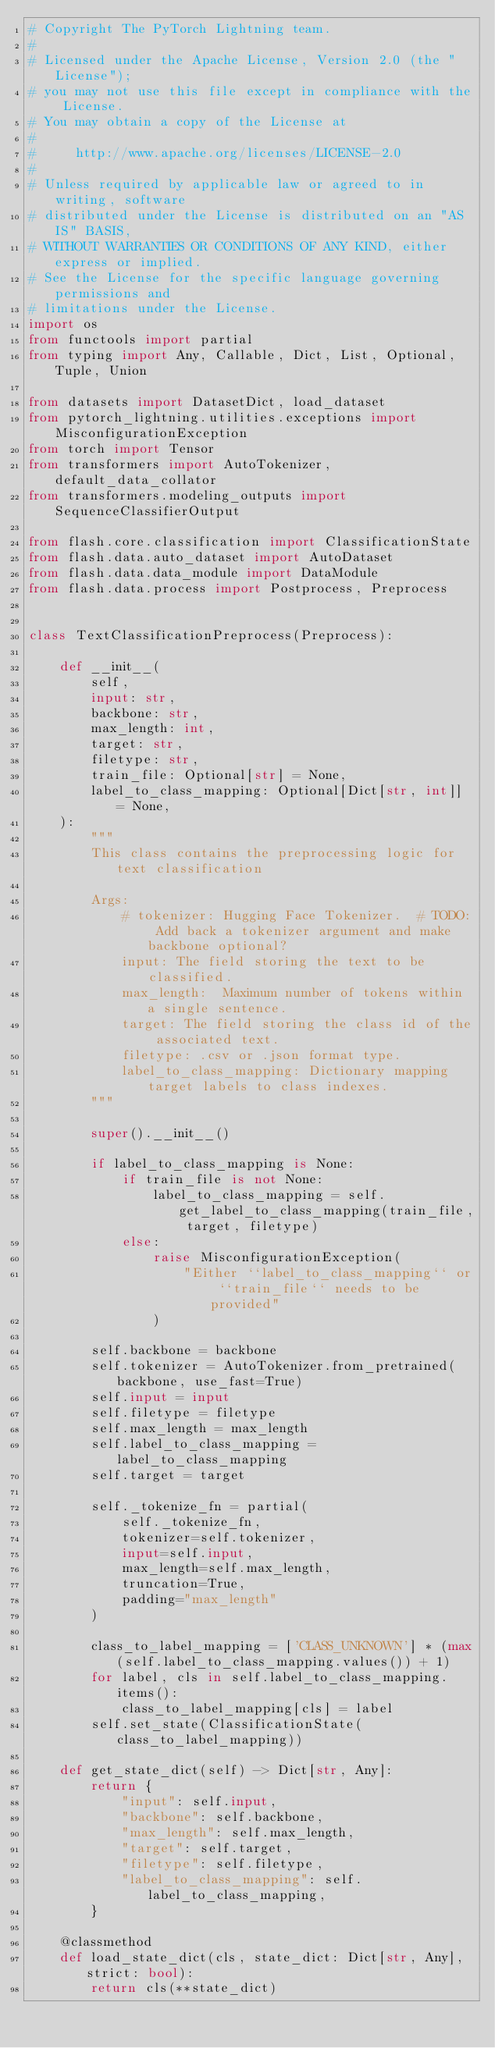Convert code to text. <code><loc_0><loc_0><loc_500><loc_500><_Python_># Copyright The PyTorch Lightning team.
#
# Licensed under the Apache License, Version 2.0 (the "License");
# you may not use this file except in compliance with the License.
# You may obtain a copy of the License at
#
#     http://www.apache.org/licenses/LICENSE-2.0
#
# Unless required by applicable law or agreed to in writing, software
# distributed under the License is distributed on an "AS IS" BASIS,
# WITHOUT WARRANTIES OR CONDITIONS OF ANY KIND, either express or implied.
# See the License for the specific language governing permissions and
# limitations under the License.
import os
from functools import partial
from typing import Any, Callable, Dict, List, Optional, Tuple, Union

from datasets import DatasetDict, load_dataset
from pytorch_lightning.utilities.exceptions import MisconfigurationException
from torch import Tensor
from transformers import AutoTokenizer, default_data_collator
from transformers.modeling_outputs import SequenceClassifierOutput

from flash.core.classification import ClassificationState
from flash.data.auto_dataset import AutoDataset
from flash.data.data_module import DataModule
from flash.data.process import Postprocess, Preprocess


class TextClassificationPreprocess(Preprocess):

    def __init__(
        self,
        input: str,
        backbone: str,
        max_length: int,
        target: str,
        filetype: str,
        train_file: Optional[str] = None,
        label_to_class_mapping: Optional[Dict[str, int]] = None,
    ):
        """
        This class contains the preprocessing logic for text classification

        Args:
            # tokenizer: Hugging Face Tokenizer.  # TODO: Add back a tokenizer argument and make backbone optional?
            input: The field storing the text to be classified.
            max_length:  Maximum number of tokens within a single sentence.
            target: The field storing the class id of the associated text.
            filetype: .csv or .json format type.
            label_to_class_mapping: Dictionary mapping target labels to class indexes.
        """

        super().__init__()

        if label_to_class_mapping is None:
            if train_file is not None:
                label_to_class_mapping = self.get_label_to_class_mapping(train_file, target, filetype)
            else:
                raise MisconfigurationException(
                    "Either ``label_to_class_mapping`` or ``train_file`` needs to be provided"
                )

        self.backbone = backbone
        self.tokenizer = AutoTokenizer.from_pretrained(backbone, use_fast=True)
        self.input = input
        self.filetype = filetype
        self.max_length = max_length
        self.label_to_class_mapping = label_to_class_mapping
        self.target = target

        self._tokenize_fn = partial(
            self._tokenize_fn,
            tokenizer=self.tokenizer,
            input=self.input,
            max_length=self.max_length,
            truncation=True,
            padding="max_length"
        )

        class_to_label_mapping = ['CLASS_UNKNOWN'] * (max(self.label_to_class_mapping.values()) + 1)
        for label, cls in self.label_to_class_mapping.items():
            class_to_label_mapping[cls] = label
        self.set_state(ClassificationState(class_to_label_mapping))

    def get_state_dict(self) -> Dict[str, Any]:
        return {
            "input": self.input,
            "backbone": self.backbone,
            "max_length": self.max_length,
            "target": self.target,
            "filetype": self.filetype,
            "label_to_class_mapping": self.label_to_class_mapping,
        }

    @classmethod
    def load_state_dict(cls, state_dict: Dict[str, Any], strict: bool):
        return cls(**state_dict)
</code> 